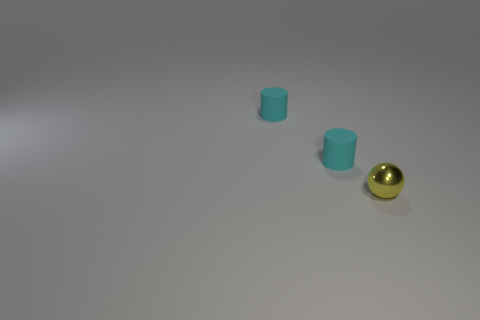How many objects are tiny cyan rubber cylinders or large gray metallic objects?
Make the answer very short. 2. How many other things are the same material as the small yellow ball?
Make the answer very short. 0. Are any cyan objects visible?
Your answer should be compact. Yes. Is there a yellow thing that has the same size as the metallic sphere?
Your answer should be very brief. No. Are there any objects to the left of the yellow sphere?
Keep it short and to the point. Yes. How many small cyan cylinders have the same material as the yellow ball?
Your answer should be compact. 0. Are there any other things that have the same shape as the tiny yellow metallic object?
Make the answer very short. No. How many things are either things that are on the left side of the tiny metallic sphere or small yellow metallic spheres?
Make the answer very short. 3. How many other things are there of the same size as the yellow object?
Offer a terse response. 2. The small metallic ball has what color?
Provide a short and direct response. Yellow. 